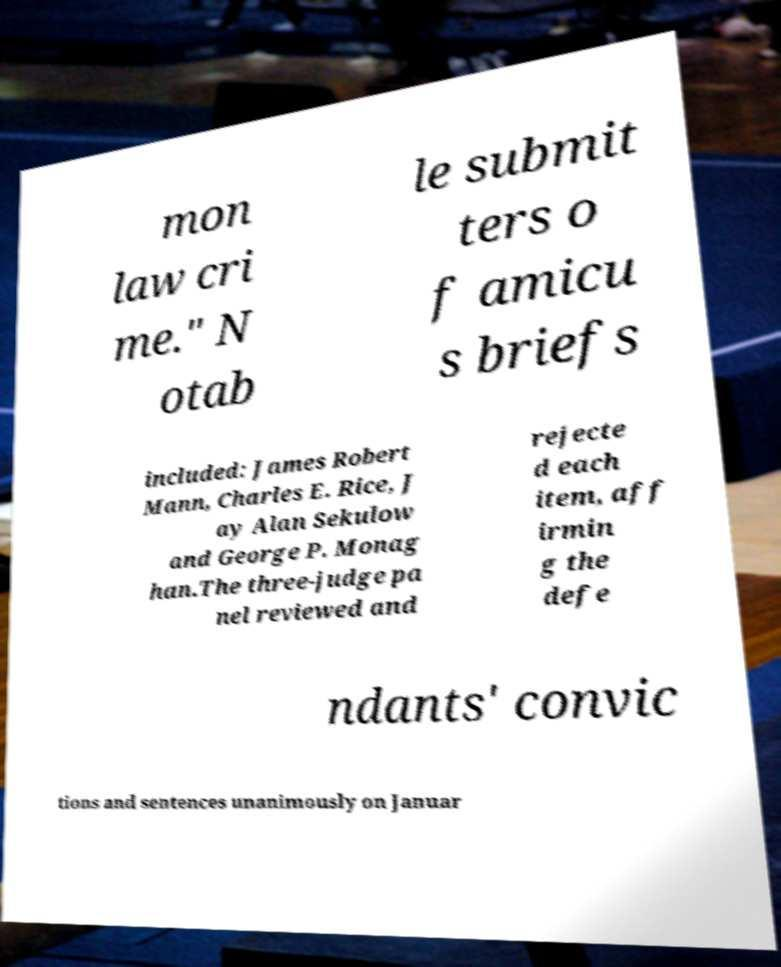For documentation purposes, I need the text within this image transcribed. Could you provide that? mon law cri me." N otab le submit ters o f amicu s briefs included: James Robert Mann, Charles E. Rice, J ay Alan Sekulow and George P. Monag han.The three-judge pa nel reviewed and rejecte d each item, aff irmin g the defe ndants' convic tions and sentences unanimously on Januar 